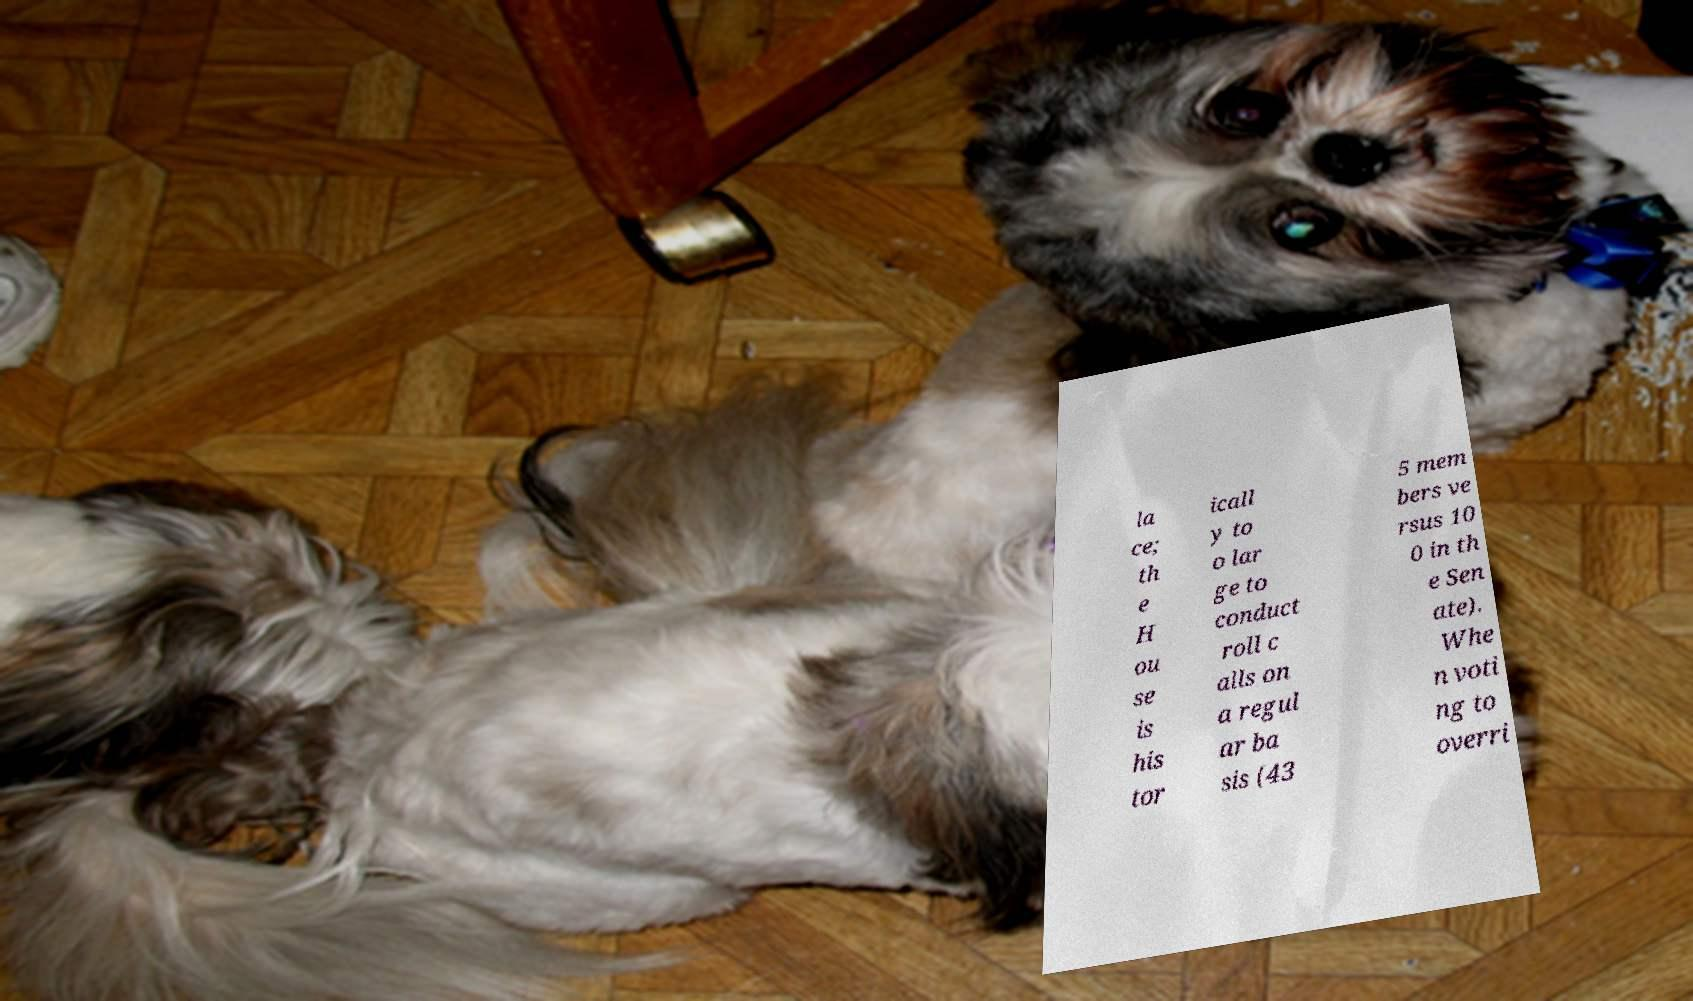Can you read and provide the text displayed in the image?This photo seems to have some interesting text. Can you extract and type it out for me? la ce; th e H ou se is his tor icall y to o lar ge to conduct roll c alls on a regul ar ba sis (43 5 mem bers ve rsus 10 0 in th e Sen ate). Whe n voti ng to overri 